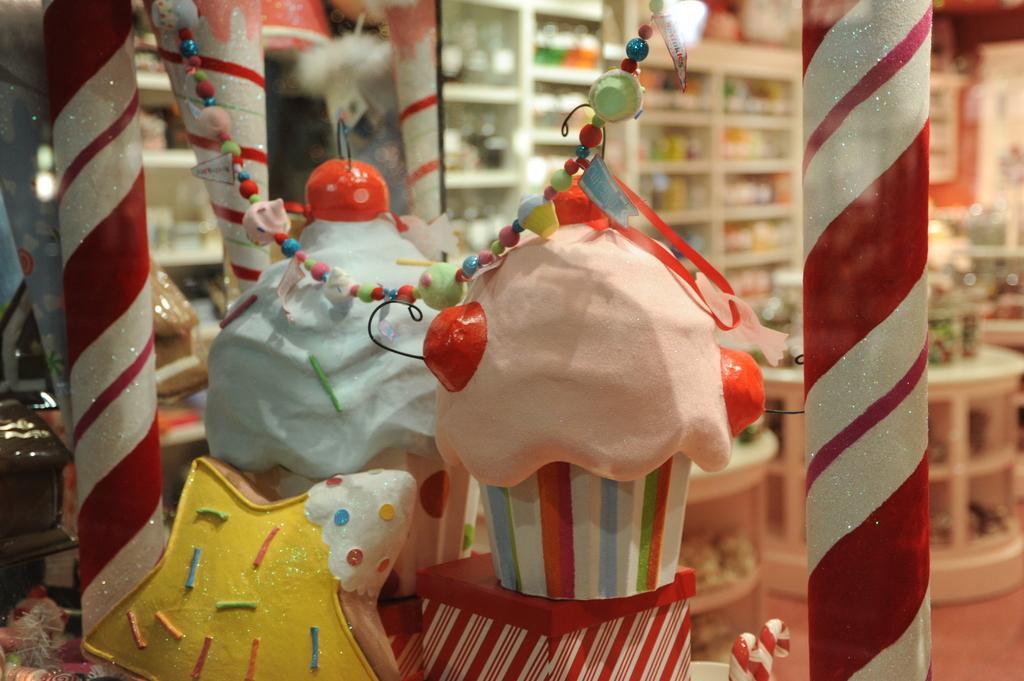How would you summarize this image in a sentence or two? This looks like a store and they are numerous objects which are available in the store and i can see a red color mat. 